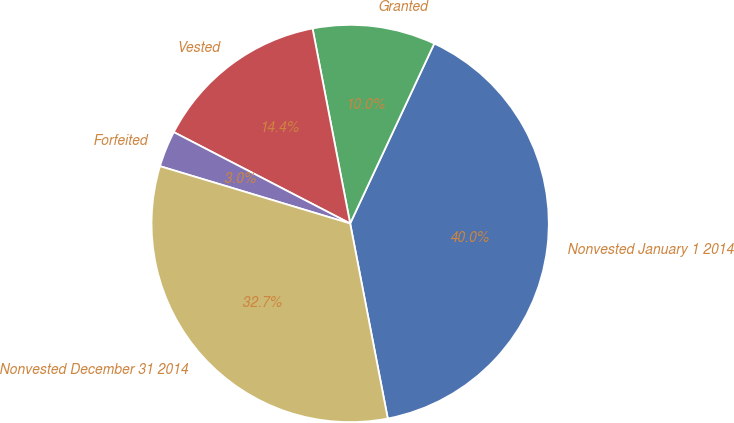<chart> <loc_0><loc_0><loc_500><loc_500><pie_chart><fcel>Nonvested January 1 2014<fcel>Granted<fcel>Vested<fcel>Forfeited<fcel>Nonvested December 31 2014<nl><fcel>40.01%<fcel>9.99%<fcel>14.36%<fcel>2.95%<fcel>32.69%<nl></chart> 